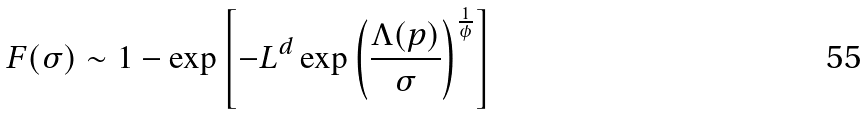<formula> <loc_0><loc_0><loc_500><loc_500>F ( \sigma ) \sim 1 - \exp \left [ - L ^ { d } \exp \left ( \frac { \Lambda ( p ) } { \sigma } \right ) ^ { \frac { 1 } { \phi } } \right ]</formula> 